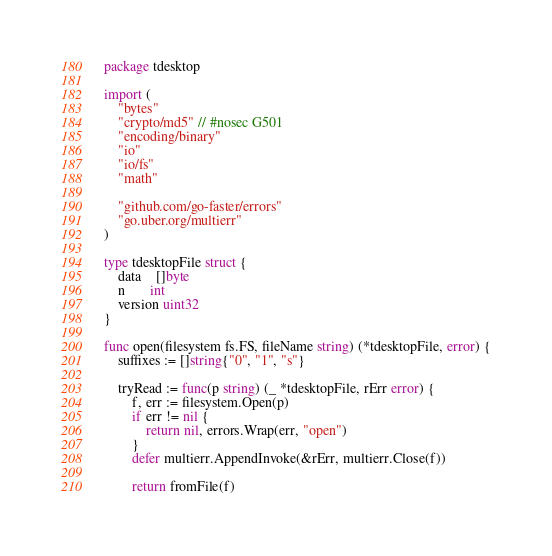<code> <loc_0><loc_0><loc_500><loc_500><_Go_>package tdesktop

import (
	"bytes"
	"crypto/md5" // #nosec G501
	"encoding/binary"
	"io"
	"io/fs"
	"math"

	"github.com/go-faster/errors"
	"go.uber.org/multierr"
)

type tdesktopFile struct {
	data    []byte
	n       int
	version uint32
}

func open(filesystem fs.FS, fileName string) (*tdesktopFile, error) {
	suffixes := []string{"0", "1", "s"}

	tryRead := func(p string) (_ *tdesktopFile, rErr error) {
		f, err := filesystem.Open(p)
		if err != nil {
			return nil, errors.Wrap(err, "open")
		}
		defer multierr.AppendInvoke(&rErr, multierr.Close(f))

		return fromFile(f)</code> 